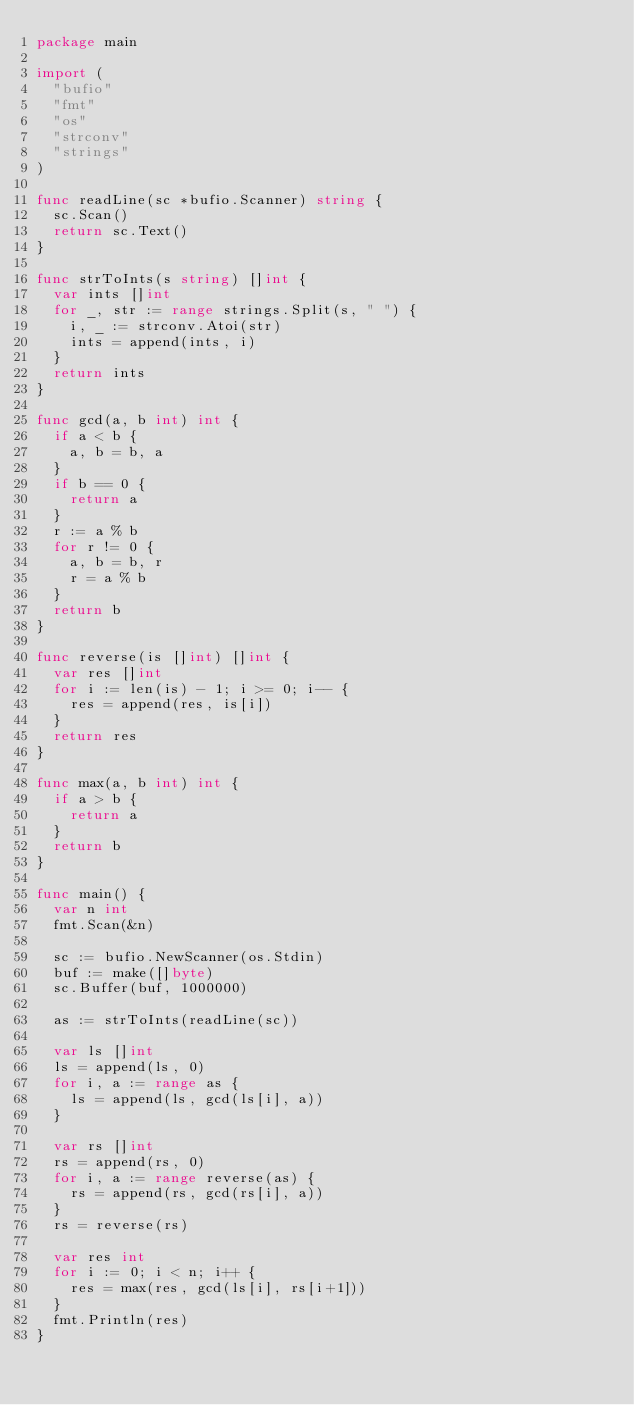<code> <loc_0><loc_0><loc_500><loc_500><_Go_>package main

import (
	"bufio"
	"fmt"
	"os"
	"strconv"
	"strings"
)

func readLine(sc *bufio.Scanner) string {
	sc.Scan()
	return sc.Text()
}

func strToInts(s string) []int {
	var ints []int
	for _, str := range strings.Split(s, " ") {
		i, _ := strconv.Atoi(str)
		ints = append(ints, i)
	}
	return ints
}

func gcd(a, b int) int {
	if a < b {
		a, b = b, a
	}
	if b == 0 {
		return a
	}
	r := a % b
	for r != 0 {
		a, b = b, r
		r = a % b
	}
	return b
}

func reverse(is []int) []int {
	var res []int
	for i := len(is) - 1; i >= 0; i-- {
		res = append(res, is[i])
	}
	return res
}

func max(a, b int) int {
	if a > b {
		return a
	}
	return b
}

func main() {
	var n int
	fmt.Scan(&n)

	sc := bufio.NewScanner(os.Stdin)
	buf := make([]byte)
	sc.Buffer(buf, 1000000)

	as := strToInts(readLine(sc))

	var ls []int
	ls = append(ls, 0)
	for i, a := range as {
		ls = append(ls, gcd(ls[i], a))
	}

	var rs []int
	rs = append(rs, 0)
	for i, a := range reverse(as) {
		rs = append(rs, gcd(rs[i], a))
	}
	rs = reverse(rs)

	var res int
	for i := 0; i < n; i++ {
		res = max(res, gcd(ls[i], rs[i+1]))
	}
	fmt.Println(res)
}
</code> 